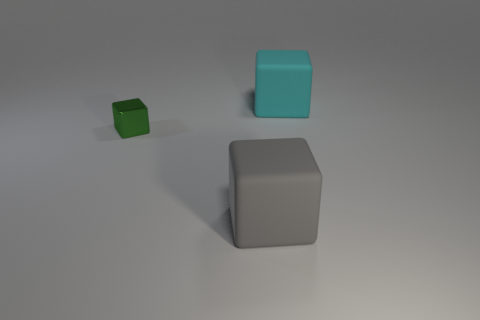Subtract all large cubes. How many cubes are left? 1 Add 1 green things. How many objects exist? 4 Add 1 big gray cubes. How many big gray cubes are left? 2 Add 3 yellow shiny balls. How many yellow shiny balls exist? 3 Subtract 1 green cubes. How many objects are left? 2 Subtract all big green cylinders. Subtract all cyan blocks. How many objects are left? 2 